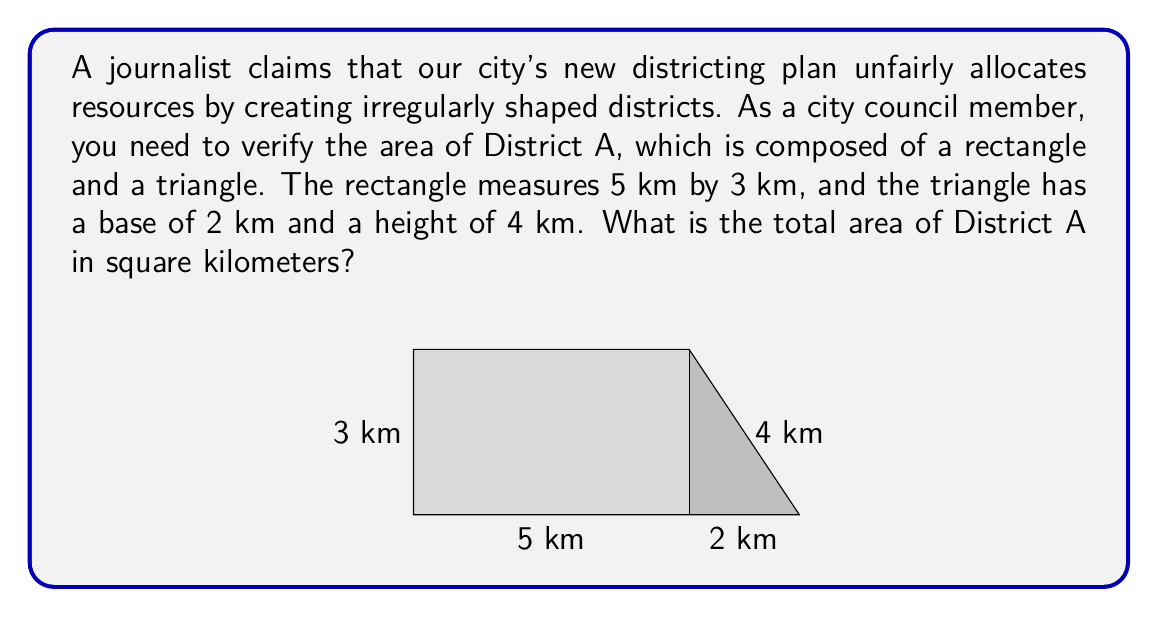Could you help me with this problem? To calculate the total area of District A, we need to sum the areas of the rectangle and the triangle:

1. Area of the rectangle:
   $A_r = l \times w$
   $A_r = 5 \text{ km} \times 3 \text{ km} = 15 \text{ km}^2$

2. Area of the triangle:
   $A_t = \frac{1}{2} \times b \times h$
   $A_t = \frac{1}{2} \times 2 \text{ km} \times 4 \text{ km} = 4 \text{ km}^2$

3. Total area of District A:
   $A_{total} = A_r + A_t$
   $A_{total} = 15 \text{ km}^2 + 4 \text{ km}^2 = 19 \text{ km}^2$

Therefore, the total area of District A is 19 square kilometers.
Answer: 19 km² 